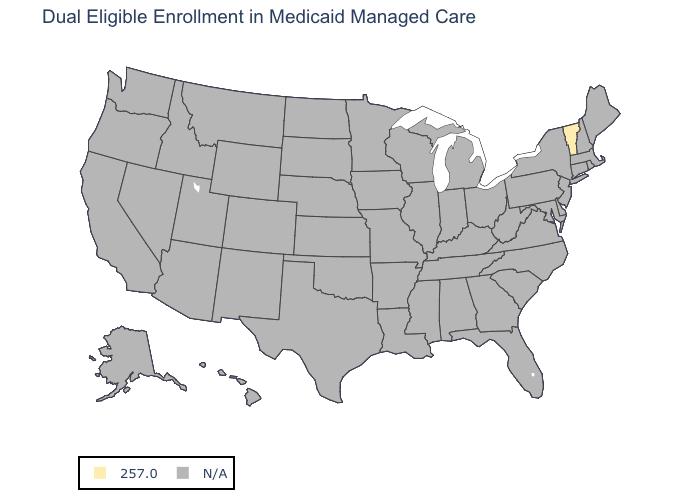Which states have the lowest value in the Northeast?
Quick response, please. Vermont. What is the value of Wisconsin?
Be succinct. N/A. Name the states that have a value in the range N/A?
Keep it brief. Alabama, Alaska, Arizona, Arkansas, California, Colorado, Connecticut, Delaware, Florida, Georgia, Hawaii, Idaho, Illinois, Indiana, Iowa, Kansas, Kentucky, Louisiana, Maine, Maryland, Massachusetts, Michigan, Minnesota, Mississippi, Missouri, Montana, Nebraska, Nevada, New Hampshire, New Jersey, New Mexico, New York, North Carolina, North Dakota, Ohio, Oklahoma, Oregon, Pennsylvania, Rhode Island, South Carolina, South Dakota, Tennessee, Texas, Utah, Virginia, Washington, West Virginia, Wisconsin, Wyoming. What is the value of North Carolina?
Keep it brief. N/A. Name the states that have a value in the range N/A?
Concise answer only. Alabama, Alaska, Arizona, Arkansas, California, Colorado, Connecticut, Delaware, Florida, Georgia, Hawaii, Idaho, Illinois, Indiana, Iowa, Kansas, Kentucky, Louisiana, Maine, Maryland, Massachusetts, Michigan, Minnesota, Mississippi, Missouri, Montana, Nebraska, Nevada, New Hampshire, New Jersey, New Mexico, New York, North Carolina, North Dakota, Ohio, Oklahoma, Oregon, Pennsylvania, Rhode Island, South Carolina, South Dakota, Tennessee, Texas, Utah, Virginia, Washington, West Virginia, Wisconsin, Wyoming. Which states have the lowest value in the USA?
Give a very brief answer. Vermont. What is the value of Kansas?
Answer briefly. N/A. Does the map have missing data?
Quick response, please. Yes. Name the states that have a value in the range N/A?
Write a very short answer. Alabama, Alaska, Arizona, Arkansas, California, Colorado, Connecticut, Delaware, Florida, Georgia, Hawaii, Idaho, Illinois, Indiana, Iowa, Kansas, Kentucky, Louisiana, Maine, Maryland, Massachusetts, Michigan, Minnesota, Mississippi, Missouri, Montana, Nebraska, Nevada, New Hampshire, New Jersey, New Mexico, New York, North Carolina, North Dakota, Ohio, Oklahoma, Oregon, Pennsylvania, Rhode Island, South Carolina, South Dakota, Tennessee, Texas, Utah, Virginia, Washington, West Virginia, Wisconsin, Wyoming. 